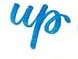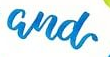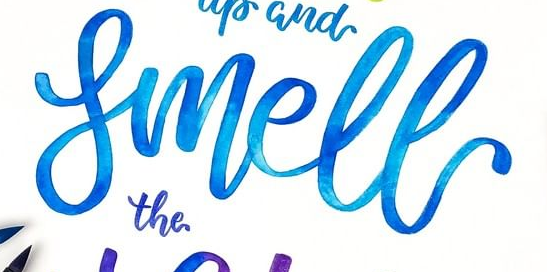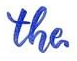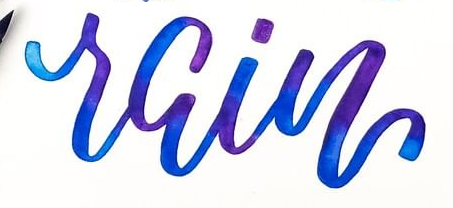What text appears in these images from left to right, separated by a semicolon? up; and; Smell; the; rain 